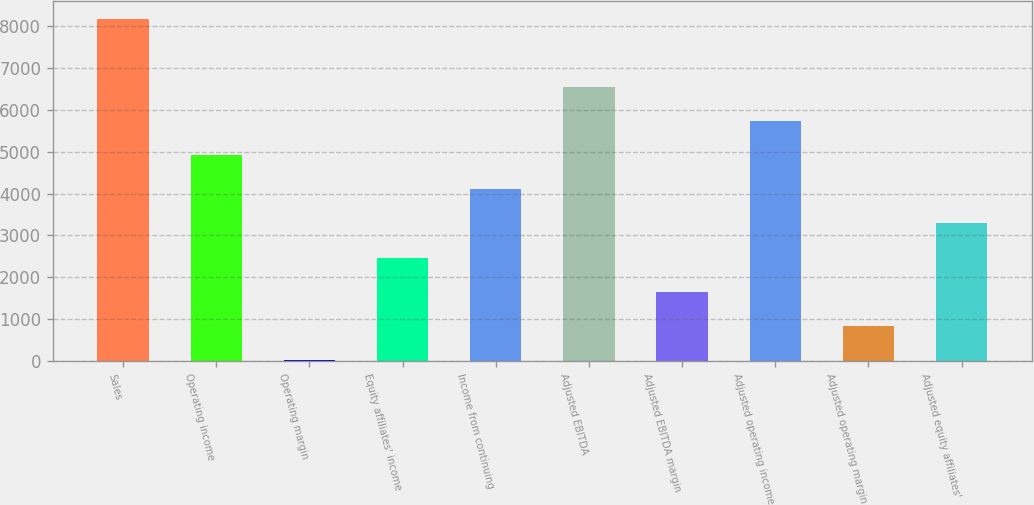Convert chart. <chart><loc_0><loc_0><loc_500><loc_500><bar_chart><fcel>Sales<fcel>Operating income<fcel>Operating margin<fcel>Equity affiliates' income<fcel>Income from continuing<fcel>Adjusted EBITDA<fcel>Adjusted EBITDA margin<fcel>Adjusted operating income<fcel>Adjusted operating margin<fcel>Adjusted equity affiliates'<nl><fcel>8187.6<fcel>4919.6<fcel>17.6<fcel>2468.6<fcel>4102.6<fcel>6553.6<fcel>1651.6<fcel>5736.6<fcel>834.6<fcel>3285.6<nl></chart> 